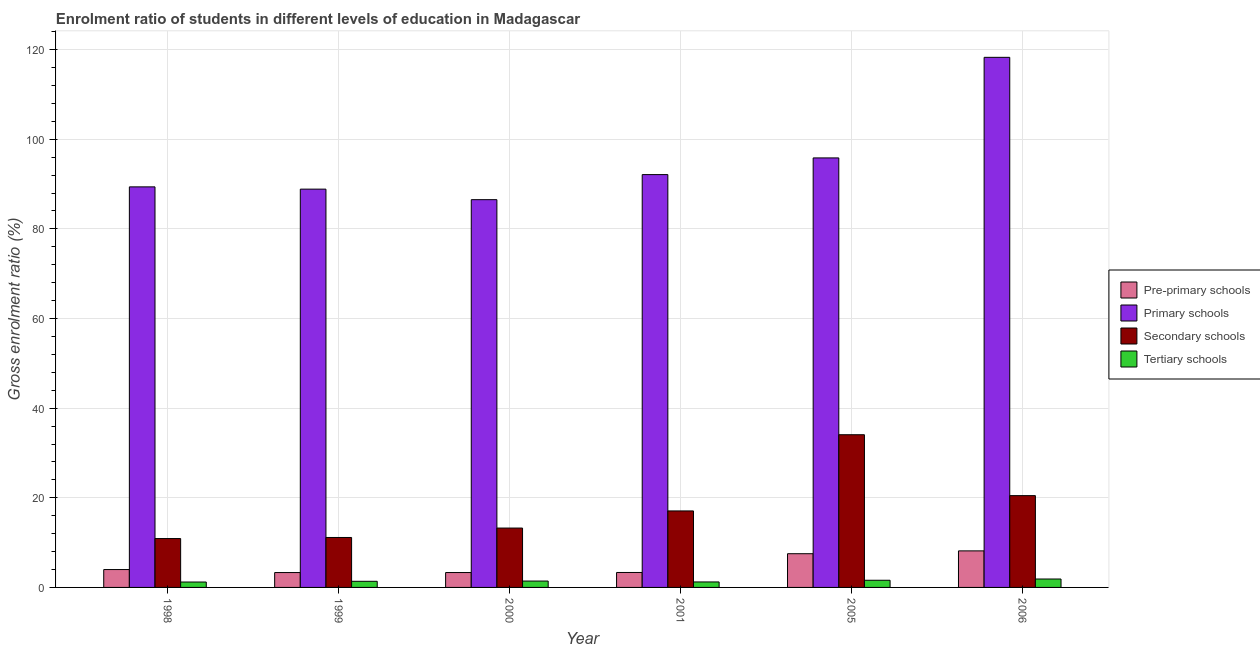Are the number of bars on each tick of the X-axis equal?
Offer a terse response. Yes. How many bars are there on the 2nd tick from the left?
Give a very brief answer. 4. What is the gross enrolment ratio in primary schools in 2001?
Provide a short and direct response. 92.12. Across all years, what is the maximum gross enrolment ratio in pre-primary schools?
Offer a terse response. 8.15. Across all years, what is the minimum gross enrolment ratio in secondary schools?
Make the answer very short. 10.91. In which year was the gross enrolment ratio in primary schools maximum?
Give a very brief answer. 2006. What is the total gross enrolment ratio in primary schools in the graph?
Your answer should be compact. 571.04. What is the difference between the gross enrolment ratio in primary schools in 2001 and that in 2006?
Your response must be concise. -26.17. What is the difference between the gross enrolment ratio in pre-primary schools in 2005 and the gross enrolment ratio in tertiary schools in 1998?
Your answer should be compact. 3.53. What is the average gross enrolment ratio in primary schools per year?
Offer a very short reply. 95.17. In the year 2005, what is the difference between the gross enrolment ratio in tertiary schools and gross enrolment ratio in primary schools?
Provide a succinct answer. 0. In how many years, is the gross enrolment ratio in primary schools greater than 40 %?
Make the answer very short. 6. What is the ratio of the gross enrolment ratio in tertiary schools in 1998 to that in 1999?
Offer a very short reply. 0.88. Is the difference between the gross enrolment ratio in primary schools in 2005 and 2006 greater than the difference between the gross enrolment ratio in tertiary schools in 2005 and 2006?
Provide a succinct answer. No. What is the difference between the highest and the second highest gross enrolment ratio in pre-primary schools?
Ensure brevity in your answer.  0.63. What is the difference between the highest and the lowest gross enrolment ratio in tertiary schools?
Keep it short and to the point. 0.67. In how many years, is the gross enrolment ratio in pre-primary schools greater than the average gross enrolment ratio in pre-primary schools taken over all years?
Provide a short and direct response. 2. What does the 4th bar from the left in 2005 represents?
Make the answer very short. Tertiary schools. What does the 3rd bar from the right in 1998 represents?
Provide a succinct answer. Primary schools. How many bars are there?
Provide a succinct answer. 24. Are all the bars in the graph horizontal?
Keep it short and to the point. No. What is the difference between two consecutive major ticks on the Y-axis?
Offer a very short reply. 20. Are the values on the major ticks of Y-axis written in scientific E-notation?
Give a very brief answer. No. Does the graph contain any zero values?
Your answer should be very brief. No. Does the graph contain grids?
Offer a terse response. Yes. Where does the legend appear in the graph?
Offer a terse response. Center right. How many legend labels are there?
Offer a terse response. 4. What is the title of the graph?
Offer a very short reply. Enrolment ratio of students in different levels of education in Madagascar. Does "Social Awareness" appear as one of the legend labels in the graph?
Your response must be concise. No. What is the label or title of the X-axis?
Your answer should be very brief. Year. What is the Gross enrolment ratio (%) of Pre-primary schools in 1998?
Keep it short and to the point. 3.99. What is the Gross enrolment ratio (%) of Primary schools in 1998?
Offer a terse response. 89.38. What is the Gross enrolment ratio (%) of Secondary schools in 1998?
Offer a very short reply. 10.91. What is the Gross enrolment ratio (%) of Tertiary schools in 1998?
Your answer should be very brief. 1.21. What is the Gross enrolment ratio (%) of Pre-primary schools in 1999?
Your answer should be compact. 3.32. What is the Gross enrolment ratio (%) in Primary schools in 1999?
Your answer should be compact. 88.88. What is the Gross enrolment ratio (%) of Secondary schools in 1999?
Offer a terse response. 11.15. What is the Gross enrolment ratio (%) of Tertiary schools in 1999?
Provide a succinct answer. 1.37. What is the Gross enrolment ratio (%) of Pre-primary schools in 2000?
Give a very brief answer. 3.32. What is the Gross enrolment ratio (%) in Primary schools in 2000?
Make the answer very short. 86.53. What is the Gross enrolment ratio (%) of Secondary schools in 2000?
Offer a terse response. 13.25. What is the Gross enrolment ratio (%) of Tertiary schools in 2000?
Your answer should be very brief. 1.42. What is the Gross enrolment ratio (%) of Pre-primary schools in 2001?
Keep it short and to the point. 3.34. What is the Gross enrolment ratio (%) in Primary schools in 2001?
Offer a terse response. 92.12. What is the Gross enrolment ratio (%) of Secondary schools in 2001?
Offer a very short reply. 17.07. What is the Gross enrolment ratio (%) in Tertiary schools in 2001?
Offer a very short reply. 1.22. What is the Gross enrolment ratio (%) of Pre-primary schools in 2005?
Keep it short and to the point. 7.52. What is the Gross enrolment ratio (%) in Primary schools in 2005?
Provide a succinct answer. 95.84. What is the Gross enrolment ratio (%) in Secondary schools in 2005?
Your answer should be very brief. 34.07. What is the Gross enrolment ratio (%) in Tertiary schools in 2005?
Give a very brief answer. 1.6. What is the Gross enrolment ratio (%) in Pre-primary schools in 2006?
Your answer should be very brief. 8.15. What is the Gross enrolment ratio (%) in Primary schools in 2006?
Provide a short and direct response. 118.29. What is the Gross enrolment ratio (%) in Secondary schools in 2006?
Your answer should be compact. 20.48. What is the Gross enrolment ratio (%) in Tertiary schools in 2006?
Your answer should be compact. 1.88. Across all years, what is the maximum Gross enrolment ratio (%) of Pre-primary schools?
Offer a very short reply. 8.15. Across all years, what is the maximum Gross enrolment ratio (%) of Primary schools?
Offer a terse response. 118.29. Across all years, what is the maximum Gross enrolment ratio (%) of Secondary schools?
Give a very brief answer. 34.07. Across all years, what is the maximum Gross enrolment ratio (%) in Tertiary schools?
Keep it short and to the point. 1.88. Across all years, what is the minimum Gross enrolment ratio (%) in Pre-primary schools?
Offer a terse response. 3.32. Across all years, what is the minimum Gross enrolment ratio (%) in Primary schools?
Offer a very short reply. 86.53. Across all years, what is the minimum Gross enrolment ratio (%) of Secondary schools?
Your response must be concise. 10.91. Across all years, what is the minimum Gross enrolment ratio (%) of Tertiary schools?
Provide a succinct answer. 1.21. What is the total Gross enrolment ratio (%) in Pre-primary schools in the graph?
Your answer should be very brief. 29.64. What is the total Gross enrolment ratio (%) of Primary schools in the graph?
Offer a terse response. 571.04. What is the total Gross enrolment ratio (%) in Secondary schools in the graph?
Provide a succinct answer. 106.93. What is the total Gross enrolment ratio (%) in Tertiary schools in the graph?
Your response must be concise. 8.7. What is the difference between the Gross enrolment ratio (%) in Pre-primary schools in 1998 and that in 1999?
Your answer should be compact. 0.67. What is the difference between the Gross enrolment ratio (%) in Primary schools in 1998 and that in 1999?
Offer a terse response. 0.51. What is the difference between the Gross enrolment ratio (%) of Secondary schools in 1998 and that in 1999?
Make the answer very short. -0.24. What is the difference between the Gross enrolment ratio (%) in Tertiary schools in 1998 and that in 1999?
Keep it short and to the point. -0.16. What is the difference between the Gross enrolment ratio (%) in Pre-primary schools in 1998 and that in 2000?
Offer a terse response. 0.67. What is the difference between the Gross enrolment ratio (%) in Primary schools in 1998 and that in 2000?
Give a very brief answer. 2.86. What is the difference between the Gross enrolment ratio (%) in Secondary schools in 1998 and that in 2000?
Your answer should be very brief. -2.34. What is the difference between the Gross enrolment ratio (%) of Tertiary schools in 1998 and that in 2000?
Your response must be concise. -0.22. What is the difference between the Gross enrolment ratio (%) in Pre-primary schools in 1998 and that in 2001?
Ensure brevity in your answer.  0.65. What is the difference between the Gross enrolment ratio (%) of Primary schools in 1998 and that in 2001?
Offer a terse response. -2.74. What is the difference between the Gross enrolment ratio (%) in Secondary schools in 1998 and that in 2001?
Provide a succinct answer. -6.16. What is the difference between the Gross enrolment ratio (%) in Tertiary schools in 1998 and that in 2001?
Give a very brief answer. -0.02. What is the difference between the Gross enrolment ratio (%) of Pre-primary schools in 1998 and that in 2005?
Provide a succinct answer. -3.53. What is the difference between the Gross enrolment ratio (%) in Primary schools in 1998 and that in 2005?
Offer a very short reply. -6.46. What is the difference between the Gross enrolment ratio (%) of Secondary schools in 1998 and that in 2005?
Make the answer very short. -23.17. What is the difference between the Gross enrolment ratio (%) of Tertiary schools in 1998 and that in 2005?
Provide a succinct answer. -0.39. What is the difference between the Gross enrolment ratio (%) of Pre-primary schools in 1998 and that in 2006?
Your answer should be very brief. -4.17. What is the difference between the Gross enrolment ratio (%) of Primary schools in 1998 and that in 2006?
Your answer should be compact. -28.9. What is the difference between the Gross enrolment ratio (%) of Secondary schools in 1998 and that in 2006?
Provide a succinct answer. -9.58. What is the difference between the Gross enrolment ratio (%) of Tertiary schools in 1998 and that in 2006?
Offer a terse response. -0.67. What is the difference between the Gross enrolment ratio (%) of Pre-primary schools in 1999 and that in 2000?
Your response must be concise. -0. What is the difference between the Gross enrolment ratio (%) in Primary schools in 1999 and that in 2000?
Ensure brevity in your answer.  2.35. What is the difference between the Gross enrolment ratio (%) of Secondary schools in 1999 and that in 2000?
Make the answer very short. -2.1. What is the difference between the Gross enrolment ratio (%) in Tertiary schools in 1999 and that in 2000?
Keep it short and to the point. -0.05. What is the difference between the Gross enrolment ratio (%) in Pre-primary schools in 1999 and that in 2001?
Provide a succinct answer. -0.02. What is the difference between the Gross enrolment ratio (%) in Primary schools in 1999 and that in 2001?
Give a very brief answer. -3.24. What is the difference between the Gross enrolment ratio (%) in Secondary schools in 1999 and that in 2001?
Provide a succinct answer. -5.92. What is the difference between the Gross enrolment ratio (%) of Tertiary schools in 1999 and that in 2001?
Your answer should be very brief. 0.15. What is the difference between the Gross enrolment ratio (%) of Pre-primary schools in 1999 and that in 2005?
Keep it short and to the point. -4.2. What is the difference between the Gross enrolment ratio (%) of Primary schools in 1999 and that in 2005?
Provide a short and direct response. -6.97. What is the difference between the Gross enrolment ratio (%) of Secondary schools in 1999 and that in 2005?
Your response must be concise. -22.93. What is the difference between the Gross enrolment ratio (%) of Tertiary schools in 1999 and that in 2005?
Ensure brevity in your answer.  -0.23. What is the difference between the Gross enrolment ratio (%) of Pre-primary schools in 1999 and that in 2006?
Provide a succinct answer. -4.83. What is the difference between the Gross enrolment ratio (%) in Primary schools in 1999 and that in 2006?
Provide a succinct answer. -29.41. What is the difference between the Gross enrolment ratio (%) of Secondary schools in 1999 and that in 2006?
Keep it short and to the point. -9.34. What is the difference between the Gross enrolment ratio (%) in Tertiary schools in 1999 and that in 2006?
Offer a terse response. -0.51. What is the difference between the Gross enrolment ratio (%) in Pre-primary schools in 2000 and that in 2001?
Your answer should be compact. -0.01. What is the difference between the Gross enrolment ratio (%) in Primary schools in 2000 and that in 2001?
Give a very brief answer. -5.59. What is the difference between the Gross enrolment ratio (%) in Secondary schools in 2000 and that in 2001?
Ensure brevity in your answer.  -3.82. What is the difference between the Gross enrolment ratio (%) in Tertiary schools in 2000 and that in 2001?
Offer a terse response. 0.2. What is the difference between the Gross enrolment ratio (%) of Pre-primary schools in 2000 and that in 2005?
Provide a short and direct response. -4.2. What is the difference between the Gross enrolment ratio (%) in Primary schools in 2000 and that in 2005?
Offer a terse response. -9.32. What is the difference between the Gross enrolment ratio (%) of Secondary schools in 2000 and that in 2005?
Give a very brief answer. -20.83. What is the difference between the Gross enrolment ratio (%) of Tertiary schools in 2000 and that in 2005?
Your answer should be compact. -0.18. What is the difference between the Gross enrolment ratio (%) of Pre-primary schools in 2000 and that in 2006?
Provide a short and direct response. -4.83. What is the difference between the Gross enrolment ratio (%) in Primary schools in 2000 and that in 2006?
Ensure brevity in your answer.  -31.76. What is the difference between the Gross enrolment ratio (%) of Secondary schools in 2000 and that in 2006?
Provide a succinct answer. -7.24. What is the difference between the Gross enrolment ratio (%) of Tertiary schools in 2000 and that in 2006?
Your answer should be very brief. -0.46. What is the difference between the Gross enrolment ratio (%) in Pre-primary schools in 2001 and that in 2005?
Ensure brevity in your answer.  -4.19. What is the difference between the Gross enrolment ratio (%) in Primary schools in 2001 and that in 2005?
Offer a very short reply. -3.73. What is the difference between the Gross enrolment ratio (%) in Secondary schools in 2001 and that in 2005?
Your answer should be compact. -17.01. What is the difference between the Gross enrolment ratio (%) of Tertiary schools in 2001 and that in 2005?
Your answer should be compact. -0.38. What is the difference between the Gross enrolment ratio (%) in Pre-primary schools in 2001 and that in 2006?
Give a very brief answer. -4.82. What is the difference between the Gross enrolment ratio (%) of Primary schools in 2001 and that in 2006?
Offer a terse response. -26.17. What is the difference between the Gross enrolment ratio (%) of Secondary schools in 2001 and that in 2006?
Keep it short and to the point. -3.42. What is the difference between the Gross enrolment ratio (%) of Tertiary schools in 2001 and that in 2006?
Ensure brevity in your answer.  -0.66. What is the difference between the Gross enrolment ratio (%) in Pre-primary schools in 2005 and that in 2006?
Your response must be concise. -0.63. What is the difference between the Gross enrolment ratio (%) of Primary schools in 2005 and that in 2006?
Give a very brief answer. -22.44. What is the difference between the Gross enrolment ratio (%) in Secondary schools in 2005 and that in 2006?
Ensure brevity in your answer.  13.59. What is the difference between the Gross enrolment ratio (%) of Tertiary schools in 2005 and that in 2006?
Offer a terse response. -0.28. What is the difference between the Gross enrolment ratio (%) in Pre-primary schools in 1998 and the Gross enrolment ratio (%) in Primary schools in 1999?
Provide a short and direct response. -84.89. What is the difference between the Gross enrolment ratio (%) of Pre-primary schools in 1998 and the Gross enrolment ratio (%) of Secondary schools in 1999?
Offer a terse response. -7.16. What is the difference between the Gross enrolment ratio (%) in Pre-primary schools in 1998 and the Gross enrolment ratio (%) in Tertiary schools in 1999?
Provide a succinct answer. 2.62. What is the difference between the Gross enrolment ratio (%) of Primary schools in 1998 and the Gross enrolment ratio (%) of Secondary schools in 1999?
Give a very brief answer. 78.24. What is the difference between the Gross enrolment ratio (%) of Primary schools in 1998 and the Gross enrolment ratio (%) of Tertiary schools in 1999?
Provide a succinct answer. 88.02. What is the difference between the Gross enrolment ratio (%) in Secondary schools in 1998 and the Gross enrolment ratio (%) in Tertiary schools in 1999?
Provide a succinct answer. 9.54. What is the difference between the Gross enrolment ratio (%) of Pre-primary schools in 1998 and the Gross enrolment ratio (%) of Primary schools in 2000?
Your response must be concise. -82.54. What is the difference between the Gross enrolment ratio (%) in Pre-primary schools in 1998 and the Gross enrolment ratio (%) in Secondary schools in 2000?
Give a very brief answer. -9.26. What is the difference between the Gross enrolment ratio (%) of Pre-primary schools in 1998 and the Gross enrolment ratio (%) of Tertiary schools in 2000?
Give a very brief answer. 2.57. What is the difference between the Gross enrolment ratio (%) in Primary schools in 1998 and the Gross enrolment ratio (%) in Secondary schools in 2000?
Your response must be concise. 76.14. What is the difference between the Gross enrolment ratio (%) of Primary schools in 1998 and the Gross enrolment ratio (%) of Tertiary schools in 2000?
Keep it short and to the point. 87.96. What is the difference between the Gross enrolment ratio (%) in Secondary schools in 1998 and the Gross enrolment ratio (%) in Tertiary schools in 2000?
Your answer should be compact. 9.48. What is the difference between the Gross enrolment ratio (%) of Pre-primary schools in 1998 and the Gross enrolment ratio (%) of Primary schools in 2001?
Keep it short and to the point. -88.13. What is the difference between the Gross enrolment ratio (%) in Pre-primary schools in 1998 and the Gross enrolment ratio (%) in Secondary schools in 2001?
Your response must be concise. -13.08. What is the difference between the Gross enrolment ratio (%) in Pre-primary schools in 1998 and the Gross enrolment ratio (%) in Tertiary schools in 2001?
Your answer should be compact. 2.77. What is the difference between the Gross enrolment ratio (%) in Primary schools in 1998 and the Gross enrolment ratio (%) in Secondary schools in 2001?
Keep it short and to the point. 72.31. What is the difference between the Gross enrolment ratio (%) of Primary schools in 1998 and the Gross enrolment ratio (%) of Tertiary schools in 2001?
Make the answer very short. 88.16. What is the difference between the Gross enrolment ratio (%) in Secondary schools in 1998 and the Gross enrolment ratio (%) in Tertiary schools in 2001?
Offer a very short reply. 9.68. What is the difference between the Gross enrolment ratio (%) in Pre-primary schools in 1998 and the Gross enrolment ratio (%) in Primary schools in 2005?
Your answer should be compact. -91.86. What is the difference between the Gross enrolment ratio (%) in Pre-primary schools in 1998 and the Gross enrolment ratio (%) in Secondary schools in 2005?
Provide a short and direct response. -30.09. What is the difference between the Gross enrolment ratio (%) in Pre-primary schools in 1998 and the Gross enrolment ratio (%) in Tertiary schools in 2005?
Ensure brevity in your answer.  2.39. What is the difference between the Gross enrolment ratio (%) in Primary schools in 1998 and the Gross enrolment ratio (%) in Secondary schools in 2005?
Make the answer very short. 55.31. What is the difference between the Gross enrolment ratio (%) in Primary schools in 1998 and the Gross enrolment ratio (%) in Tertiary schools in 2005?
Ensure brevity in your answer.  87.78. What is the difference between the Gross enrolment ratio (%) of Secondary schools in 1998 and the Gross enrolment ratio (%) of Tertiary schools in 2005?
Provide a succinct answer. 9.31. What is the difference between the Gross enrolment ratio (%) of Pre-primary schools in 1998 and the Gross enrolment ratio (%) of Primary schools in 2006?
Ensure brevity in your answer.  -114.3. What is the difference between the Gross enrolment ratio (%) of Pre-primary schools in 1998 and the Gross enrolment ratio (%) of Secondary schools in 2006?
Offer a very short reply. -16.5. What is the difference between the Gross enrolment ratio (%) of Pre-primary schools in 1998 and the Gross enrolment ratio (%) of Tertiary schools in 2006?
Your response must be concise. 2.11. What is the difference between the Gross enrolment ratio (%) of Primary schools in 1998 and the Gross enrolment ratio (%) of Secondary schools in 2006?
Provide a succinct answer. 68.9. What is the difference between the Gross enrolment ratio (%) of Primary schools in 1998 and the Gross enrolment ratio (%) of Tertiary schools in 2006?
Provide a short and direct response. 87.5. What is the difference between the Gross enrolment ratio (%) of Secondary schools in 1998 and the Gross enrolment ratio (%) of Tertiary schools in 2006?
Your answer should be very brief. 9.03. What is the difference between the Gross enrolment ratio (%) in Pre-primary schools in 1999 and the Gross enrolment ratio (%) in Primary schools in 2000?
Give a very brief answer. -83.21. What is the difference between the Gross enrolment ratio (%) in Pre-primary schools in 1999 and the Gross enrolment ratio (%) in Secondary schools in 2000?
Give a very brief answer. -9.93. What is the difference between the Gross enrolment ratio (%) in Pre-primary schools in 1999 and the Gross enrolment ratio (%) in Tertiary schools in 2000?
Provide a succinct answer. 1.9. What is the difference between the Gross enrolment ratio (%) of Primary schools in 1999 and the Gross enrolment ratio (%) of Secondary schools in 2000?
Your answer should be compact. 75.63. What is the difference between the Gross enrolment ratio (%) in Primary schools in 1999 and the Gross enrolment ratio (%) in Tertiary schools in 2000?
Ensure brevity in your answer.  87.45. What is the difference between the Gross enrolment ratio (%) of Secondary schools in 1999 and the Gross enrolment ratio (%) of Tertiary schools in 2000?
Provide a short and direct response. 9.73. What is the difference between the Gross enrolment ratio (%) of Pre-primary schools in 1999 and the Gross enrolment ratio (%) of Primary schools in 2001?
Offer a very short reply. -88.8. What is the difference between the Gross enrolment ratio (%) of Pre-primary schools in 1999 and the Gross enrolment ratio (%) of Secondary schools in 2001?
Make the answer very short. -13.75. What is the difference between the Gross enrolment ratio (%) in Pre-primary schools in 1999 and the Gross enrolment ratio (%) in Tertiary schools in 2001?
Your answer should be compact. 2.1. What is the difference between the Gross enrolment ratio (%) in Primary schools in 1999 and the Gross enrolment ratio (%) in Secondary schools in 2001?
Ensure brevity in your answer.  71.81. What is the difference between the Gross enrolment ratio (%) of Primary schools in 1999 and the Gross enrolment ratio (%) of Tertiary schools in 2001?
Provide a short and direct response. 87.65. What is the difference between the Gross enrolment ratio (%) in Secondary schools in 1999 and the Gross enrolment ratio (%) in Tertiary schools in 2001?
Make the answer very short. 9.93. What is the difference between the Gross enrolment ratio (%) of Pre-primary schools in 1999 and the Gross enrolment ratio (%) of Primary schools in 2005?
Ensure brevity in your answer.  -92.53. What is the difference between the Gross enrolment ratio (%) in Pre-primary schools in 1999 and the Gross enrolment ratio (%) in Secondary schools in 2005?
Keep it short and to the point. -30.76. What is the difference between the Gross enrolment ratio (%) of Pre-primary schools in 1999 and the Gross enrolment ratio (%) of Tertiary schools in 2005?
Offer a very short reply. 1.72. What is the difference between the Gross enrolment ratio (%) of Primary schools in 1999 and the Gross enrolment ratio (%) of Secondary schools in 2005?
Provide a short and direct response. 54.8. What is the difference between the Gross enrolment ratio (%) in Primary schools in 1999 and the Gross enrolment ratio (%) in Tertiary schools in 2005?
Make the answer very short. 87.28. What is the difference between the Gross enrolment ratio (%) of Secondary schools in 1999 and the Gross enrolment ratio (%) of Tertiary schools in 2005?
Your response must be concise. 9.55. What is the difference between the Gross enrolment ratio (%) of Pre-primary schools in 1999 and the Gross enrolment ratio (%) of Primary schools in 2006?
Keep it short and to the point. -114.97. What is the difference between the Gross enrolment ratio (%) in Pre-primary schools in 1999 and the Gross enrolment ratio (%) in Secondary schools in 2006?
Your answer should be compact. -17.17. What is the difference between the Gross enrolment ratio (%) in Pre-primary schools in 1999 and the Gross enrolment ratio (%) in Tertiary schools in 2006?
Make the answer very short. 1.44. What is the difference between the Gross enrolment ratio (%) of Primary schools in 1999 and the Gross enrolment ratio (%) of Secondary schools in 2006?
Provide a succinct answer. 68.39. What is the difference between the Gross enrolment ratio (%) in Primary schools in 1999 and the Gross enrolment ratio (%) in Tertiary schools in 2006?
Make the answer very short. 87. What is the difference between the Gross enrolment ratio (%) in Secondary schools in 1999 and the Gross enrolment ratio (%) in Tertiary schools in 2006?
Your answer should be very brief. 9.27. What is the difference between the Gross enrolment ratio (%) of Pre-primary schools in 2000 and the Gross enrolment ratio (%) of Primary schools in 2001?
Offer a terse response. -88.8. What is the difference between the Gross enrolment ratio (%) in Pre-primary schools in 2000 and the Gross enrolment ratio (%) in Secondary schools in 2001?
Provide a short and direct response. -13.75. What is the difference between the Gross enrolment ratio (%) of Pre-primary schools in 2000 and the Gross enrolment ratio (%) of Tertiary schools in 2001?
Make the answer very short. 2.1. What is the difference between the Gross enrolment ratio (%) of Primary schools in 2000 and the Gross enrolment ratio (%) of Secondary schools in 2001?
Keep it short and to the point. 69.46. What is the difference between the Gross enrolment ratio (%) in Primary schools in 2000 and the Gross enrolment ratio (%) in Tertiary schools in 2001?
Provide a succinct answer. 85.3. What is the difference between the Gross enrolment ratio (%) in Secondary schools in 2000 and the Gross enrolment ratio (%) in Tertiary schools in 2001?
Offer a very short reply. 12.03. What is the difference between the Gross enrolment ratio (%) of Pre-primary schools in 2000 and the Gross enrolment ratio (%) of Primary schools in 2005?
Provide a succinct answer. -92.52. What is the difference between the Gross enrolment ratio (%) in Pre-primary schools in 2000 and the Gross enrolment ratio (%) in Secondary schools in 2005?
Make the answer very short. -30.75. What is the difference between the Gross enrolment ratio (%) in Pre-primary schools in 2000 and the Gross enrolment ratio (%) in Tertiary schools in 2005?
Provide a succinct answer. 1.72. What is the difference between the Gross enrolment ratio (%) in Primary schools in 2000 and the Gross enrolment ratio (%) in Secondary schools in 2005?
Offer a terse response. 52.45. What is the difference between the Gross enrolment ratio (%) of Primary schools in 2000 and the Gross enrolment ratio (%) of Tertiary schools in 2005?
Your answer should be very brief. 84.93. What is the difference between the Gross enrolment ratio (%) in Secondary schools in 2000 and the Gross enrolment ratio (%) in Tertiary schools in 2005?
Make the answer very short. 11.65. What is the difference between the Gross enrolment ratio (%) of Pre-primary schools in 2000 and the Gross enrolment ratio (%) of Primary schools in 2006?
Ensure brevity in your answer.  -114.97. What is the difference between the Gross enrolment ratio (%) of Pre-primary schools in 2000 and the Gross enrolment ratio (%) of Secondary schools in 2006?
Offer a very short reply. -17.16. What is the difference between the Gross enrolment ratio (%) of Pre-primary schools in 2000 and the Gross enrolment ratio (%) of Tertiary schools in 2006?
Your answer should be very brief. 1.44. What is the difference between the Gross enrolment ratio (%) in Primary schools in 2000 and the Gross enrolment ratio (%) in Secondary schools in 2006?
Your answer should be compact. 66.04. What is the difference between the Gross enrolment ratio (%) of Primary schools in 2000 and the Gross enrolment ratio (%) of Tertiary schools in 2006?
Offer a very short reply. 84.65. What is the difference between the Gross enrolment ratio (%) of Secondary schools in 2000 and the Gross enrolment ratio (%) of Tertiary schools in 2006?
Ensure brevity in your answer.  11.37. What is the difference between the Gross enrolment ratio (%) in Pre-primary schools in 2001 and the Gross enrolment ratio (%) in Primary schools in 2005?
Keep it short and to the point. -92.51. What is the difference between the Gross enrolment ratio (%) in Pre-primary schools in 2001 and the Gross enrolment ratio (%) in Secondary schools in 2005?
Your response must be concise. -30.74. What is the difference between the Gross enrolment ratio (%) of Pre-primary schools in 2001 and the Gross enrolment ratio (%) of Tertiary schools in 2005?
Provide a short and direct response. 1.74. What is the difference between the Gross enrolment ratio (%) in Primary schools in 2001 and the Gross enrolment ratio (%) in Secondary schools in 2005?
Provide a short and direct response. 58.04. What is the difference between the Gross enrolment ratio (%) of Primary schools in 2001 and the Gross enrolment ratio (%) of Tertiary schools in 2005?
Provide a short and direct response. 90.52. What is the difference between the Gross enrolment ratio (%) in Secondary schools in 2001 and the Gross enrolment ratio (%) in Tertiary schools in 2005?
Ensure brevity in your answer.  15.47. What is the difference between the Gross enrolment ratio (%) in Pre-primary schools in 2001 and the Gross enrolment ratio (%) in Primary schools in 2006?
Your response must be concise. -114.95. What is the difference between the Gross enrolment ratio (%) in Pre-primary schools in 2001 and the Gross enrolment ratio (%) in Secondary schools in 2006?
Offer a very short reply. -17.15. What is the difference between the Gross enrolment ratio (%) in Pre-primary schools in 2001 and the Gross enrolment ratio (%) in Tertiary schools in 2006?
Give a very brief answer. 1.46. What is the difference between the Gross enrolment ratio (%) of Primary schools in 2001 and the Gross enrolment ratio (%) of Secondary schools in 2006?
Keep it short and to the point. 71.63. What is the difference between the Gross enrolment ratio (%) of Primary schools in 2001 and the Gross enrolment ratio (%) of Tertiary schools in 2006?
Provide a short and direct response. 90.24. What is the difference between the Gross enrolment ratio (%) in Secondary schools in 2001 and the Gross enrolment ratio (%) in Tertiary schools in 2006?
Make the answer very short. 15.19. What is the difference between the Gross enrolment ratio (%) of Pre-primary schools in 2005 and the Gross enrolment ratio (%) of Primary schools in 2006?
Provide a short and direct response. -110.77. What is the difference between the Gross enrolment ratio (%) in Pre-primary schools in 2005 and the Gross enrolment ratio (%) in Secondary schools in 2006?
Keep it short and to the point. -12.96. What is the difference between the Gross enrolment ratio (%) of Pre-primary schools in 2005 and the Gross enrolment ratio (%) of Tertiary schools in 2006?
Give a very brief answer. 5.64. What is the difference between the Gross enrolment ratio (%) in Primary schools in 2005 and the Gross enrolment ratio (%) in Secondary schools in 2006?
Ensure brevity in your answer.  75.36. What is the difference between the Gross enrolment ratio (%) of Primary schools in 2005 and the Gross enrolment ratio (%) of Tertiary schools in 2006?
Ensure brevity in your answer.  93.96. What is the difference between the Gross enrolment ratio (%) of Secondary schools in 2005 and the Gross enrolment ratio (%) of Tertiary schools in 2006?
Keep it short and to the point. 32.2. What is the average Gross enrolment ratio (%) in Pre-primary schools per year?
Ensure brevity in your answer.  4.94. What is the average Gross enrolment ratio (%) of Primary schools per year?
Provide a succinct answer. 95.17. What is the average Gross enrolment ratio (%) in Secondary schools per year?
Offer a terse response. 17.82. What is the average Gross enrolment ratio (%) of Tertiary schools per year?
Your answer should be compact. 1.45. In the year 1998, what is the difference between the Gross enrolment ratio (%) in Pre-primary schools and Gross enrolment ratio (%) in Primary schools?
Offer a very short reply. -85.39. In the year 1998, what is the difference between the Gross enrolment ratio (%) of Pre-primary schools and Gross enrolment ratio (%) of Secondary schools?
Keep it short and to the point. -6.92. In the year 1998, what is the difference between the Gross enrolment ratio (%) of Pre-primary schools and Gross enrolment ratio (%) of Tertiary schools?
Offer a very short reply. 2.78. In the year 1998, what is the difference between the Gross enrolment ratio (%) of Primary schools and Gross enrolment ratio (%) of Secondary schools?
Make the answer very short. 78.48. In the year 1998, what is the difference between the Gross enrolment ratio (%) in Primary schools and Gross enrolment ratio (%) in Tertiary schools?
Keep it short and to the point. 88.18. In the year 1998, what is the difference between the Gross enrolment ratio (%) in Secondary schools and Gross enrolment ratio (%) in Tertiary schools?
Make the answer very short. 9.7. In the year 1999, what is the difference between the Gross enrolment ratio (%) of Pre-primary schools and Gross enrolment ratio (%) of Primary schools?
Your response must be concise. -85.56. In the year 1999, what is the difference between the Gross enrolment ratio (%) in Pre-primary schools and Gross enrolment ratio (%) in Secondary schools?
Ensure brevity in your answer.  -7.83. In the year 1999, what is the difference between the Gross enrolment ratio (%) of Pre-primary schools and Gross enrolment ratio (%) of Tertiary schools?
Your answer should be compact. 1.95. In the year 1999, what is the difference between the Gross enrolment ratio (%) in Primary schools and Gross enrolment ratio (%) in Secondary schools?
Provide a short and direct response. 77.73. In the year 1999, what is the difference between the Gross enrolment ratio (%) of Primary schools and Gross enrolment ratio (%) of Tertiary schools?
Your answer should be very brief. 87.51. In the year 1999, what is the difference between the Gross enrolment ratio (%) of Secondary schools and Gross enrolment ratio (%) of Tertiary schools?
Offer a very short reply. 9.78. In the year 2000, what is the difference between the Gross enrolment ratio (%) of Pre-primary schools and Gross enrolment ratio (%) of Primary schools?
Keep it short and to the point. -83.21. In the year 2000, what is the difference between the Gross enrolment ratio (%) in Pre-primary schools and Gross enrolment ratio (%) in Secondary schools?
Offer a very short reply. -9.93. In the year 2000, what is the difference between the Gross enrolment ratio (%) in Pre-primary schools and Gross enrolment ratio (%) in Tertiary schools?
Give a very brief answer. 1.9. In the year 2000, what is the difference between the Gross enrolment ratio (%) in Primary schools and Gross enrolment ratio (%) in Secondary schools?
Your answer should be compact. 73.28. In the year 2000, what is the difference between the Gross enrolment ratio (%) of Primary schools and Gross enrolment ratio (%) of Tertiary schools?
Offer a very short reply. 85.1. In the year 2000, what is the difference between the Gross enrolment ratio (%) of Secondary schools and Gross enrolment ratio (%) of Tertiary schools?
Your answer should be compact. 11.83. In the year 2001, what is the difference between the Gross enrolment ratio (%) of Pre-primary schools and Gross enrolment ratio (%) of Primary schools?
Make the answer very short. -88.78. In the year 2001, what is the difference between the Gross enrolment ratio (%) of Pre-primary schools and Gross enrolment ratio (%) of Secondary schools?
Provide a succinct answer. -13.73. In the year 2001, what is the difference between the Gross enrolment ratio (%) in Pre-primary schools and Gross enrolment ratio (%) in Tertiary schools?
Your response must be concise. 2.11. In the year 2001, what is the difference between the Gross enrolment ratio (%) in Primary schools and Gross enrolment ratio (%) in Secondary schools?
Your answer should be very brief. 75.05. In the year 2001, what is the difference between the Gross enrolment ratio (%) of Primary schools and Gross enrolment ratio (%) of Tertiary schools?
Offer a very short reply. 90.9. In the year 2001, what is the difference between the Gross enrolment ratio (%) of Secondary schools and Gross enrolment ratio (%) of Tertiary schools?
Provide a short and direct response. 15.85. In the year 2005, what is the difference between the Gross enrolment ratio (%) in Pre-primary schools and Gross enrolment ratio (%) in Primary schools?
Offer a terse response. -88.32. In the year 2005, what is the difference between the Gross enrolment ratio (%) of Pre-primary schools and Gross enrolment ratio (%) of Secondary schools?
Give a very brief answer. -26.55. In the year 2005, what is the difference between the Gross enrolment ratio (%) of Pre-primary schools and Gross enrolment ratio (%) of Tertiary schools?
Offer a very short reply. 5.92. In the year 2005, what is the difference between the Gross enrolment ratio (%) of Primary schools and Gross enrolment ratio (%) of Secondary schools?
Ensure brevity in your answer.  61.77. In the year 2005, what is the difference between the Gross enrolment ratio (%) in Primary schools and Gross enrolment ratio (%) in Tertiary schools?
Ensure brevity in your answer.  94.24. In the year 2005, what is the difference between the Gross enrolment ratio (%) in Secondary schools and Gross enrolment ratio (%) in Tertiary schools?
Provide a succinct answer. 32.47. In the year 2006, what is the difference between the Gross enrolment ratio (%) in Pre-primary schools and Gross enrolment ratio (%) in Primary schools?
Ensure brevity in your answer.  -110.13. In the year 2006, what is the difference between the Gross enrolment ratio (%) in Pre-primary schools and Gross enrolment ratio (%) in Secondary schools?
Your answer should be very brief. -12.33. In the year 2006, what is the difference between the Gross enrolment ratio (%) of Pre-primary schools and Gross enrolment ratio (%) of Tertiary schools?
Your response must be concise. 6.27. In the year 2006, what is the difference between the Gross enrolment ratio (%) of Primary schools and Gross enrolment ratio (%) of Secondary schools?
Your answer should be very brief. 97.8. In the year 2006, what is the difference between the Gross enrolment ratio (%) of Primary schools and Gross enrolment ratio (%) of Tertiary schools?
Offer a very short reply. 116.41. In the year 2006, what is the difference between the Gross enrolment ratio (%) in Secondary schools and Gross enrolment ratio (%) in Tertiary schools?
Offer a terse response. 18.61. What is the ratio of the Gross enrolment ratio (%) in Pre-primary schools in 1998 to that in 1999?
Your response must be concise. 1.2. What is the ratio of the Gross enrolment ratio (%) of Primary schools in 1998 to that in 1999?
Your response must be concise. 1.01. What is the ratio of the Gross enrolment ratio (%) in Secondary schools in 1998 to that in 1999?
Keep it short and to the point. 0.98. What is the ratio of the Gross enrolment ratio (%) in Tertiary schools in 1998 to that in 1999?
Your answer should be compact. 0.88. What is the ratio of the Gross enrolment ratio (%) in Pre-primary schools in 1998 to that in 2000?
Your answer should be very brief. 1.2. What is the ratio of the Gross enrolment ratio (%) of Primary schools in 1998 to that in 2000?
Your response must be concise. 1.03. What is the ratio of the Gross enrolment ratio (%) in Secondary schools in 1998 to that in 2000?
Your response must be concise. 0.82. What is the ratio of the Gross enrolment ratio (%) of Tertiary schools in 1998 to that in 2000?
Keep it short and to the point. 0.85. What is the ratio of the Gross enrolment ratio (%) of Pre-primary schools in 1998 to that in 2001?
Give a very brief answer. 1.2. What is the ratio of the Gross enrolment ratio (%) in Primary schools in 1998 to that in 2001?
Your answer should be very brief. 0.97. What is the ratio of the Gross enrolment ratio (%) in Secondary schools in 1998 to that in 2001?
Keep it short and to the point. 0.64. What is the ratio of the Gross enrolment ratio (%) in Tertiary schools in 1998 to that in 2001?
Provide a short and direct response. 0.99. What is the ratio of the Gross enrolment ratio (%) of Pre-primary schools in 1998 to that in 2005?
Give a very brief answer. 0.53. What is the ratio of the Gross enrolment ratio (%) of Primary schools in 1998 to that in 2005?
Offer a terse response. 0.93. What is the ratio of the Gross enrolment ratio (%) in Secondary schools in 1998 to that in 2005?
Your response must be concise. 0.32. What is the ratio of the Gross enrolment ratio (%) of Tertiary schools in 1998 to that in 2005?
Provide a short and direct response. 0.75. What is the ratio of the Gross enrolment ratio (%) of Pre-primary schools in 1998 to that in 2006?
Offer a terse response. 0.49. What is the ratio of the Gross enrolment ratio (%) of Primary schools in 1998 to that in 2006?
Your response must be concise. 0.76. What is the ratio of the Gross enrolment ratio (%) in Secondary schools in 1998 to that in 2006?
Your answer should be very brief. 0.53. What is the ratio of the Gross enrolment ratio (%) in Tertiary schools in 1998 to that in 2006?
Make the answer very short. 0.64. What is the ratio of the Gross enrolment ratio (%) in Primary schools in 1999 to that in 2000?
Offer a very short reply. 1.03. What is the ratio of the Gross enrolment ratio (%) of Secondary schools in 1999 to that in 2000?
Give a very brief answer. 0.84. What is the ratio of the Gross enrolment ratio (%) of Tertiary schools in 1999 to that in 2000?
Provide a short and direct response. 0.96. What is the ratio of the Gross enrolment ratio (%) of Pre-primary schools in 1999 to that in 2001?
Offer a very short reply. 1. What is the ratio of the Gross enrolment ratio (%) in Primary schools in 1999 to that in 2001?
Offer a very short reply. 0.96. What is the ratio of the Gross enrolment ratio (%) of Secondary schools in 1999 to that in 2001?
Your answer should be compact. 0.65. What is the ratio of the Gross enrolment ratio (%) in Tertiary schools in 1999 to that in 2001?
Offer a very short reply. 1.12. What is the ratio of the Gross enrolment ratio (%) of Pre-primary schools in 1999 to that in 2005?
Ensure brevity in your answer.  0.44. What is the ratio of the Gross enrolment ratio (%) in Primary schools in 1999 to that in 2005?
Give a very brief answer. 0.93. What is the ratio of the Gross enrolment ratio (%) in Secondary schools in 1999 to that in 2005?
Your response must be concise. 0.33. What is the ratio of the Gross enrolment ratio (%) of Tertiary schools in 1999 to that in 2005?
Ensure brevity in your answer.  0.85. What is the ratio of the Gross enrolment ratio (%) of Pre-primary schools in 1999 to that in 2006?
Your response must be concise. 0.41. What is the ratio of the Gross enrolment ratio (%) of Primary schools in 1999 to that in 2006?
Provide a short and direct response. 0.75. What is the ratio of the Gross enrolment ratio (%) of Secondary schools in 1999 to that in 2006?
Keep it short and to the point. 0.54. What is the ratio of the Gross enrolment ratio (%) in Tertiary schools in 1999 to that in 2006?
Your answer should be compact. 0.73. What is the ratio of the Gross enrolment ratio (%) of Primary schools in 2000 to that in 2001?
Offer a terse response. 0.94. What is the ratio of the Gross enrolment ratio (%) of Secondary schools in 2000 to that in 2001?
Offer a terse response. 0.78. What is the ratio of the Gross enrolment ratio (%) in Tertiary schools in 2000 to that in 2001?
Your response must be concise. 1.16. What is the ratio of the Gross enrolment ratio (%) in Pre-primary schools in 2000 to that in 2005?
Your answer should be very brief. 0.44. What is the ratio of the Gross enrolment ratio (%) of Primary schools in 2000 to that in 2005?
Ensure brevity in your answer.  0.9. What is the ratio of the Gross enrolment ratio (%) of Secondary schools in 2000 to that in 2005?
Provide a succinct answer. 0.39. What is the ratio of the Gross enrolment ratio (%) in Tertiary schools in 2000 to that in 2005?
Provide a succinct answer. 0.89. What is the ratio of the Gross enrolment ratio (%) in Pre-primary schools in 2000 to that in 2006?
Provide a short and direct response. 0.41. What is the ratio of the Gross enrolment ratio (%) of Primary schools in 2000 to that in 2006?
Provide a succinct answer. 0.73. What is the ratio of the Gross enrolment ratio (%) in Secondary schools in 2000 to that in 2006?
Your response must be concise. 0.65. What is the ratio of the Gross enrolment ratio (%) of Tertiary schools in 2000 to that in 2006?
Your answer should be compact. 0.76. What is the ratio of the Gross enrolment ratio (%) in Pre-primary schools in 2001 to that in 2005?
Provide a short and direct response. 0.44. What is the ratio of the Gross enrolment ratio (%) in Primary schools in 2001 to that in 2005?
Offer a very short reply. 0.96. What is the ratio of the Gross enrolment ratio (%) of Secondary schools in 2001 to that in 2005?
Make the answer very short. 0.5. What is the ratio of the Gross enrolment ratio (%) of Tertiary schools in 2001 to that in 2005?
Provide a short and direct response. 0.76. What is the ratio of the Gross enrolment ratio (%) in Pre-primary schools in 2001 to that in 2006?
Your answer should be compact. 0.41. What is the ratio of the Gross enrolment ratio (%) of Primary schools in 2001 to that in 2006?
Ensure brevity in your answer.  0.78. What is the ratio of the Gross enrolment ratio (%) of Secondary schools in 2001 to that in 2006?
Your answer should be very brief. 0.83. What is the ratio of the Gross enrolment ratio (%) in Tertiary schools in 2001 to that in 2006?
Offer a very short reply. 0.65. What is the ratio of the Gross enrolment ratio (%) in Pre-primary schools in 2005 to that in 2006?
Your answer should be compact. 0.92. What is the ratio of the Gross enrolment ratio (%) in Primary schools in 2005 to that in 2006?
Offer a terse response. 0.81. What is the ratio of the Gross enrolment ratio (%) of Secondary schools in 2005 to that in 2006?
Your answer should be compact. 1.66. What is the ratio of the Gross enrolment ratio (%) of Tertiary schools in 2005 to that in 2006?
Give a very brief answer. 0.85. What is the difference between the highest and the second highest Gross enrolment ratio (%) in Pre-primary schools?
Provide a succinct answer. 0.63. What is the difference between the highest and the second highest Gross enrolment ratio (%) of Primary schools?
Offer a very short reply. 22.44. What is the difference between the highest and the second highest Gross enrolment ratio (%) of Secondary schools?
Your answer should be compact. 13.59. What is the difference between the highest and the second highest Gross enrolment ratio (%) in Tertiary schools?
Your answer should be very brief. 0.28. What is the difference between the highest and the lowest Gross enrolment ratio (%) in Pre-primary schools?
Provide a succinct answer. 4.83. What is the difference between the highest and the lowest Gross enrolment ratio (%) in Primary schools?
Offer a terse response. 31.76. What is the difference between the highest and the lowest Gross enrolment ratio (%) in Secondary schools?
Your response must be concise. 23.17. What is the difference between the highest and the lowest Gross enrolment ratio (%) in Tertiary schools?
Keep it short and to the point. 0.67. 